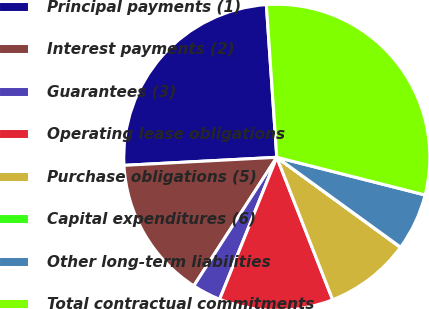Convert chart. <chart><loc_0><loc_0><loc_500><loc_500><pie_chart><fcel>Principal payments (1)<fcel>Interest payments (2)<fcel>Guarantees (3)<fcel>Operating lease obligations<fcel>Purchase obligations (5)<fcel>Capital expenditures (6)<fcel>Other long-term liabilities<fcel>Total contractual commitments<nl><fcel>24.75%<fcel>15.04%<fcel>3.03%<fcel>12.04%<fcel>9.03%<fcel>0.03%<fcel>6.03%<fcel>30.05%<nl></chart> 